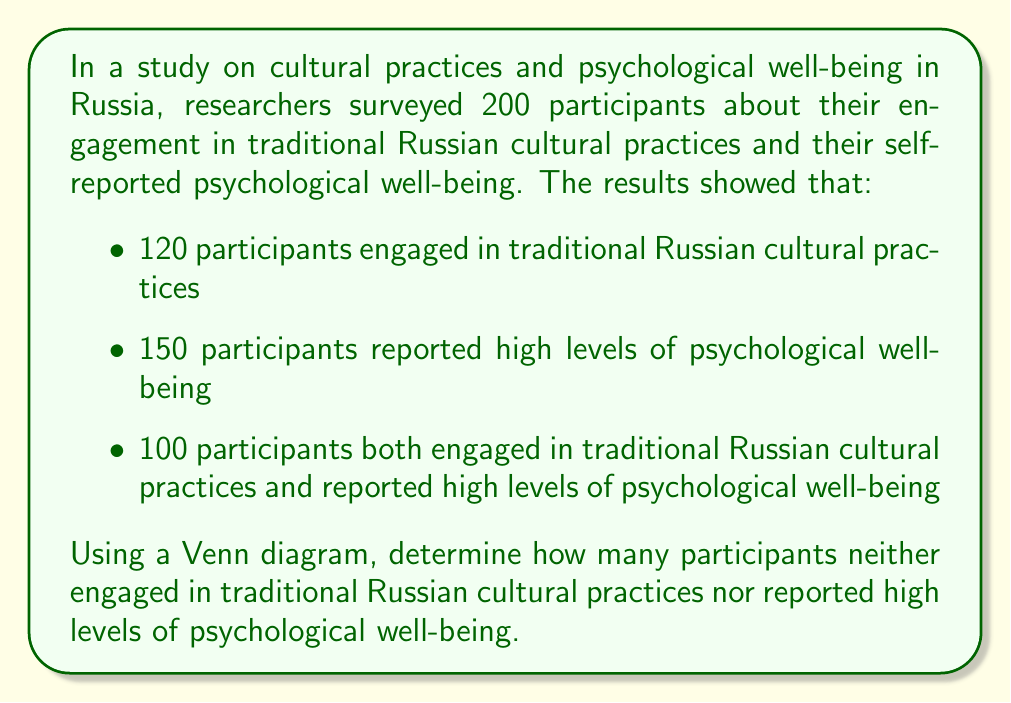Help me with this question. Let's approach this step-by-step using set theory and a Venn diagram:

1) Let's define our sets:
   A = participants who engaged in traditional Russian cultural practices
   B = participants who reported high levels of psychological well-being

2) We're given the following information:
   |A| = 120 (total in set A)
   |B| = 150 (total in set B)
   |A ∩ B| = 100 (intersection of A and B)
   |U| = 200 (total participants in the universal set)

3) Let's create a Venn diagram:

   [asy]
   unitsize(1cm);
   
   pair A = (0,0), B = (2,0);
   real r = 1.2;
   
   fill(circle(A,r), lightblue);
   fill(circle(B,r), lightgreen);
   
   draw(circle(A,r));
   draw(circle(B,r));
   
   label("A", A + (-0.7,0.7));
   label("B", B + (0.7,0.7));
   
   label("20", A + (-0.5,0));
   label("50", B + (0.5,0));
   label("100", (1,0));
   
   draw((-2,-1.5)--(4,-1.5)--(4,1.5)--(-2,1.5)--cycle);
   label("30", (3,1));
   [/asy]

4) We can calculate the number in each region:
   - A only: 120 - 100 = 20
   - B only: 150 - 100 = 50
   - A ∩ B: 100 (given)

5) To find those who are in neither set:
   |U| - (|A| + |B| - |A ∩ B|) = 200 - (120 + 150 - 100) = 200 - 170 = 30

Therefore, 30 participants neither engaged in traditional Russian cultural practices nor reported high levels of psychological well-being.
Answer: 30 participants 